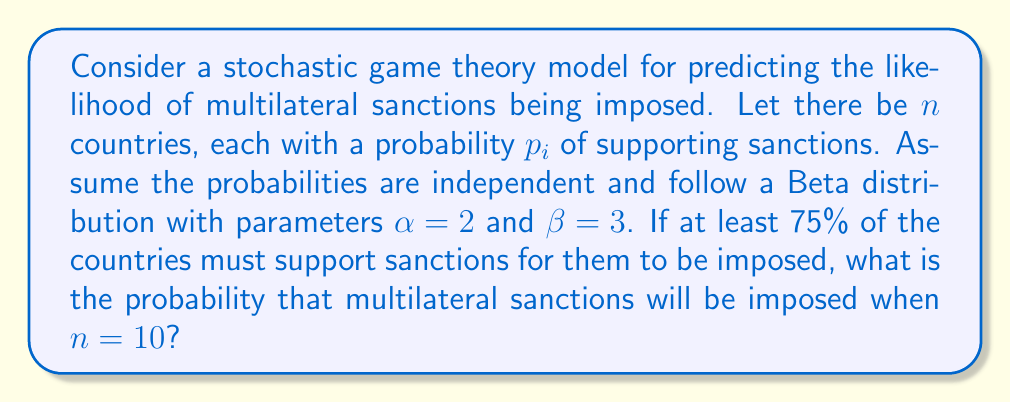Show me your answer to this math problem. 1. The probability of each country supporting sanctions follows a Beta distribution with $\alpha = 2$ and $\beta = 3$. The expected value of this distribution is:

   $$E[p_i] = \frac{\alpha}{\alpha + \beta} = \frac{2}{2 + 3} = \frac{2}{5} = 0.4$$

2. For sanctions to be imposed, at least 75% of the countries must support them. With $n = 10$ countries, this means at least 8 countries must support sanctions.

3. Let $X$ be the number of countries supporting sanctions. $X$ follows a Binomial distribution with parameters $n = 10$ and $p = 0.4$.

4. We need to calculate $P(X \geq 8)$. This is equivalent to $1 - P(X \leq 7)$.

5. Using the cumulative distribution function of the Binomial distribution:

   $$P(X \leq 7) = \sum_{k=0}^7 \binom{10}{k} (0.4)^k (0.6)^{10-k}$$

6. Calculating this sum:

   $$P(X \leq 7) \approx 0.9672$$

7. Therefore, the probability of sanctions being imposed is:

   $$P(X \geq 8) = 1 - P(X \leq 7) \approx 1 - 0.9672 = 0.0328$$
Answer: 0.0328 